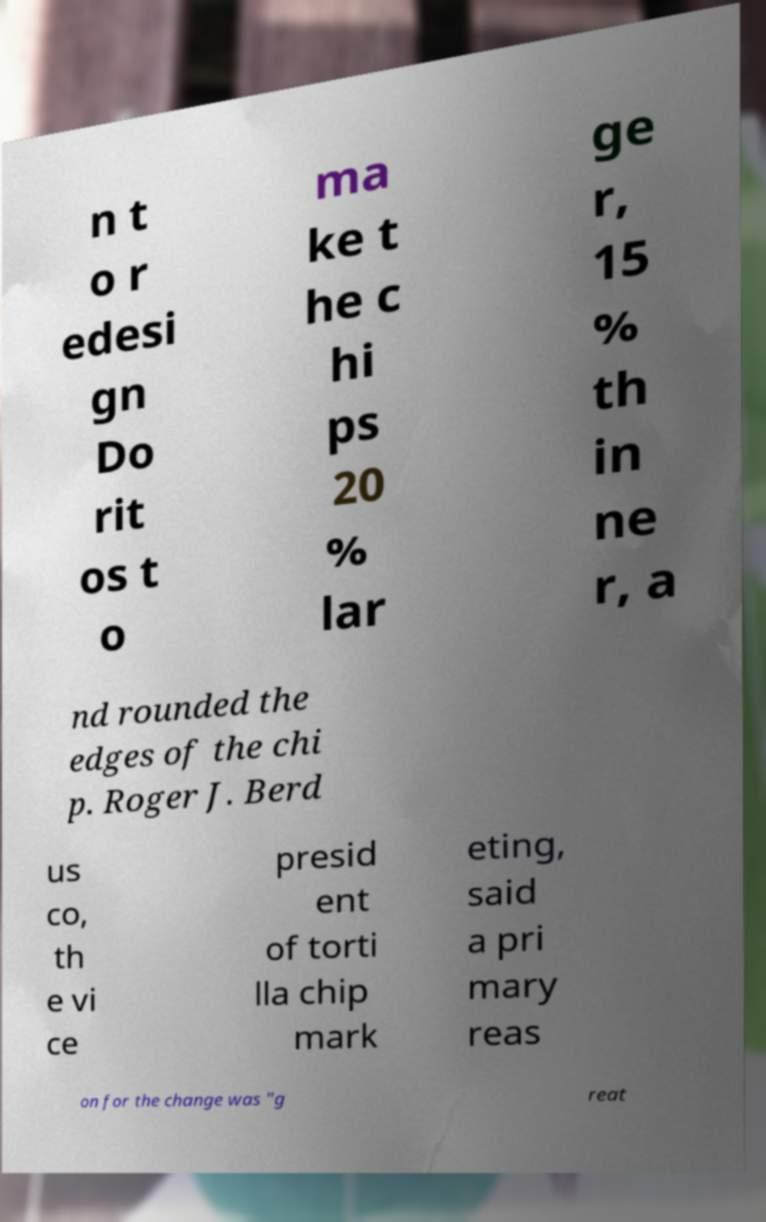Could you extract and type out the text from this image? n t o r edesi gn Do rit os t o ma ke t he c hi ps 20 % lar ge r, 15 % th in ne r, a nd rounded the edges of the chi p. Roger J. Berd us co, th e vi ce presid ent of torti lla chip mark eting, said a pri mary reas on for the change was "g reat 